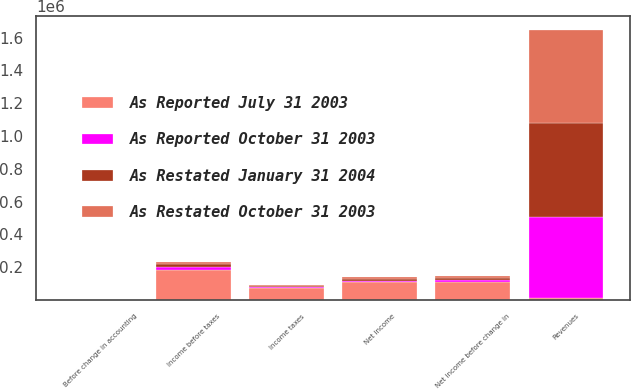Convert chart to OTSL. <chart><loc_0><loc_0><loc_500><loc_500><stacked_bar_chart><ecel><fcel>Revenues<fcel>Income before taxes<fcel>Income taxes<fcel>Net income before change in<fcel>Net income<fcel>Before change in accounting<nl><fcel>As Reported July 31 2003<fcel>10376<fcel>181406<fcel>69782<fcel>111624<fcel>111624<fcel>0.32<nl><fcel>As Restated October 31 2003<fcel>568872<fcel>17134<fcel>6758<fcel>10376<fcel>10376<fcel>0.03<nl><fcel>As Restated January 31 2004<fcel>573267<fcel>15390<fcel>5920<fcel>9470<fcel>9470<fcel>0.03<nl><fcel>As Reported October 31 2003<fcel>495384<fcel>18829<fcel>7310<fcel>11519<fcel>5160<fcel>0.03<nl></chart> 